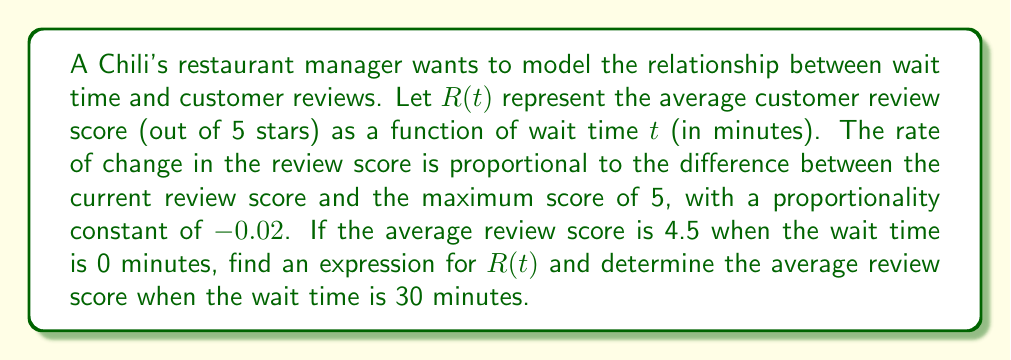Show me your answer to this math problem. 1) We can model this situation using a differential equation:
   $$\frac{dR}{dt} = -0.02(R - 5)$$

2) This is a separable differential equation. Let's solve it:
   $$\frac{dR}{R - 5} = -0.02dt$$

3) Integrating both sides:
   $$\int \frac{dR}{R - 5} = -0.02 \int dt$$
   $$\ln|R - 5| = -0.02t + C$$

4) Solving for R:
   $$R - 5 = e^{-0.02t + C} = Ae^{-0.02t}$$
   $$R = 5 + Ae^{-0.02t}$$

5) Using the initial condition R(0) = 4.5:
   $$4.5 = 5 + A$$
   $$A = -0.5$$

6) Therefore, the expression for R(t) is:
   $$R(t) = 5 - 0.5e^{-0.02t}$$

7) To find the average review score when t = 30:
   $$R(30) = 5 - 0.5e^{-0.02(30)}$$
   $$R(30) = 5 - 0.5e^{-0.6}$$
   $$R(30) \approx 4.73$$
Answer: $R(t) = 5 - 0.5e^{-0.02t}$; $R(30) \approx 4.73$ 